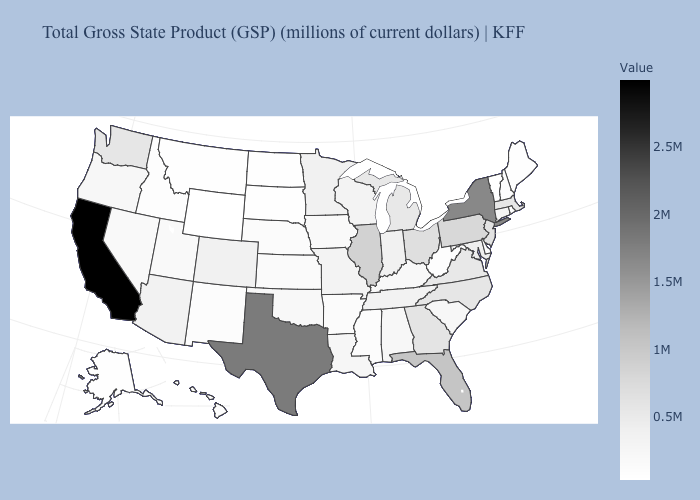Does the map have missing data?
Concise answer only. No. Does South Dakota have the lowest value in the MidWest?
Short answer required. Yes. Among the states that border Pennsylvania , which have the highest value?
Short answer required. New York. Among the states that border Colorado , does Wyoming have the lowest value?
Concise answer only. Yes. Does Colorado have a higher value than Alaska?
Keep it brief. Yes. Which states have the lowest value in the South?
Keep it brief. Delaware. Among the states that border West Virginia , which have the highest value?
Keep it brief. Pennsylvania. 